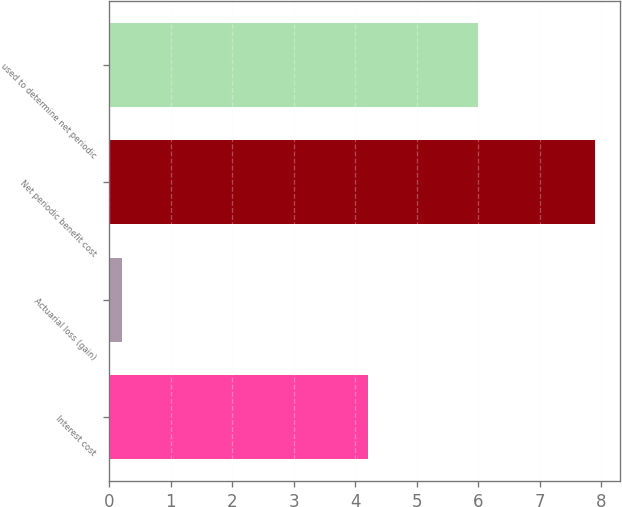Convert chart to OTSL. <chart><loc_0><loc_0><loc_500><loc_500><bar_chart><fcel>Interest cost<fcel>Actuarial loss (gain)<fcel>Net periodic benefit cost<fcel>used to determine net periodic<nl><fcel>4.2<fcel>0.2<fcel>7.9<fcel>6<nl></chart> 